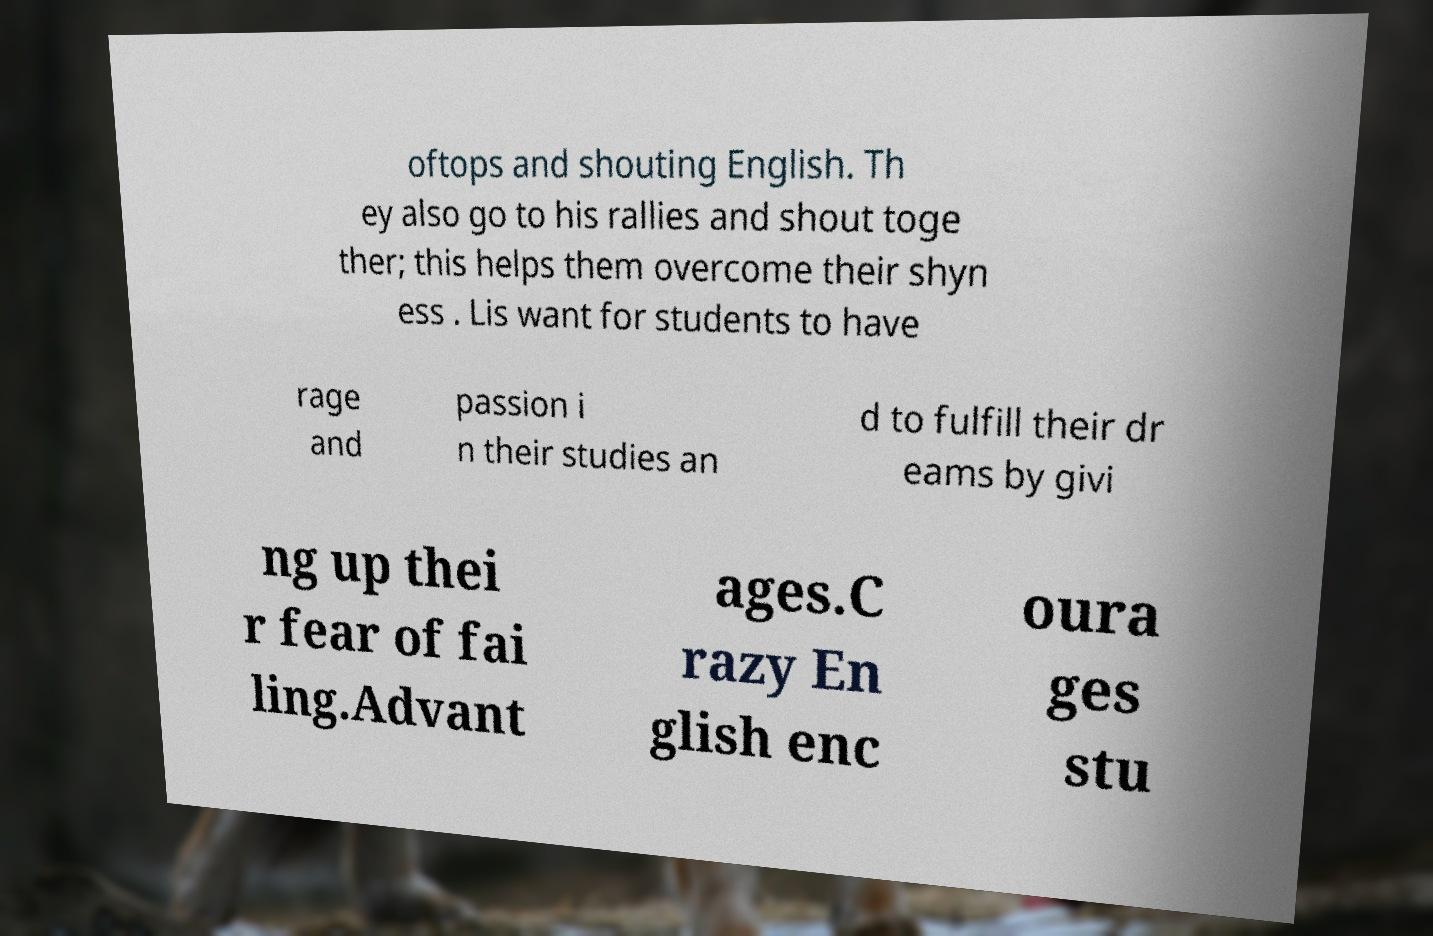What messages or text are displayed in this image? I need them in a readable, typed format. oftops and shouting English. Th ey also go to his rallies and shout toge ther; this helps them overcome their shyn ess . Lis want for students to have rage and passion i n their studies an d to fulfill their dr eams by givi ng up thei r fear of fai ling.Advant ages.C razy En glish enc oura ges stu 